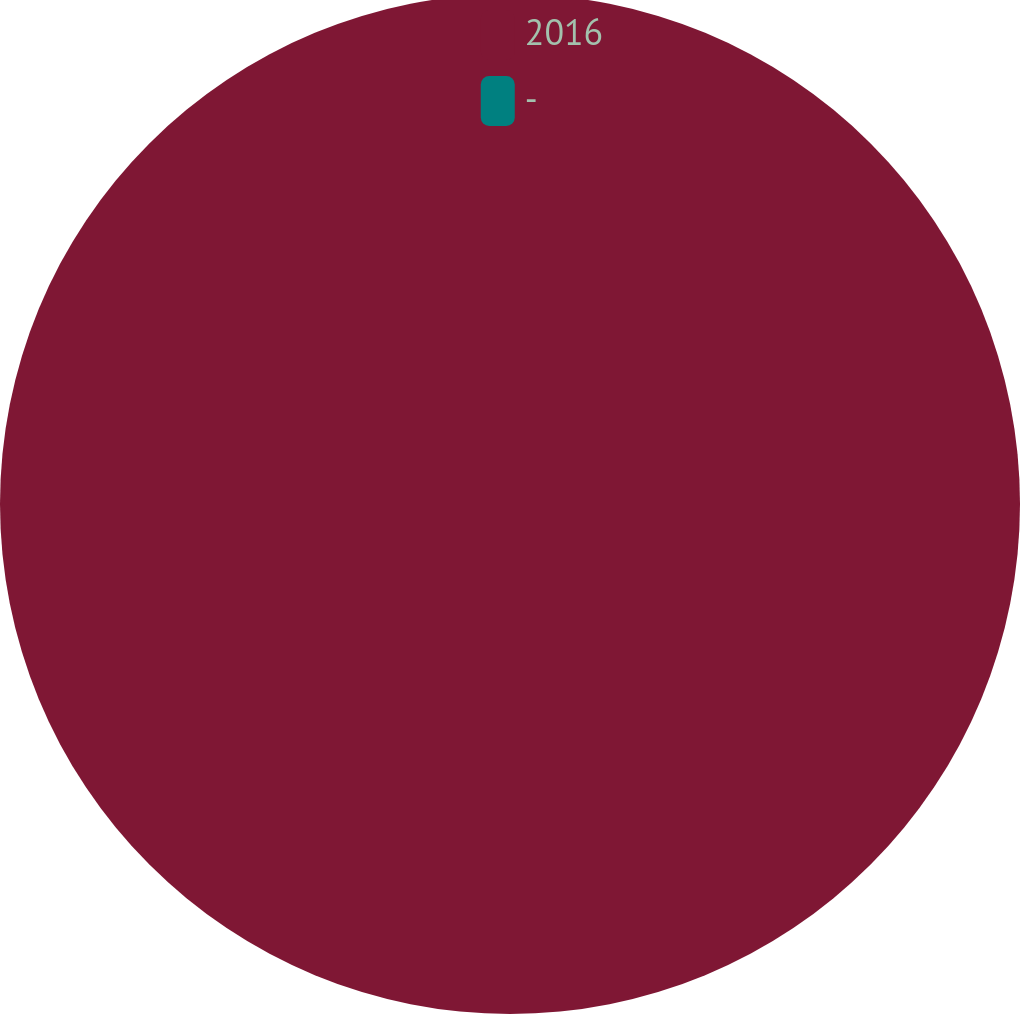Convert chart to OTSL. <chart><loc_0><loc_0><loc_500><loc_500><pie_chart><fcel>2016<fcel>-<nl><fcel>100.0%<fcel>0.0%<nl></chart> 